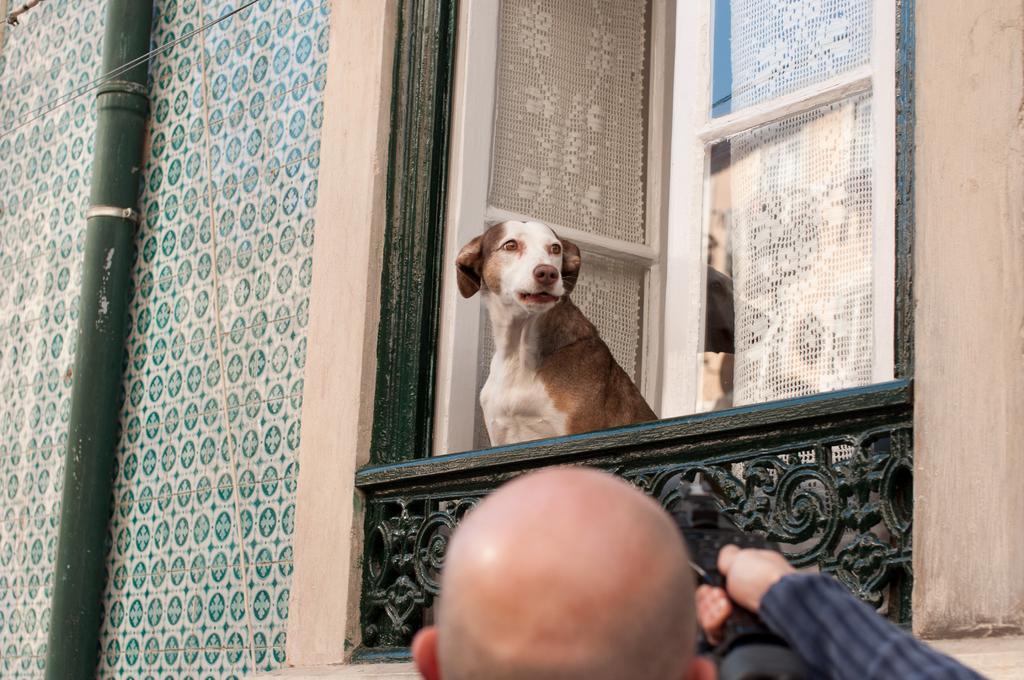In one or two sentences, can you explain what this image depicts? Here in this picture we can see a dog present in the balcony of a building present over there and behind that we can see a window and curtains on it over there and on the left side we can see a pipe present and in the front we can see a person present over there. 